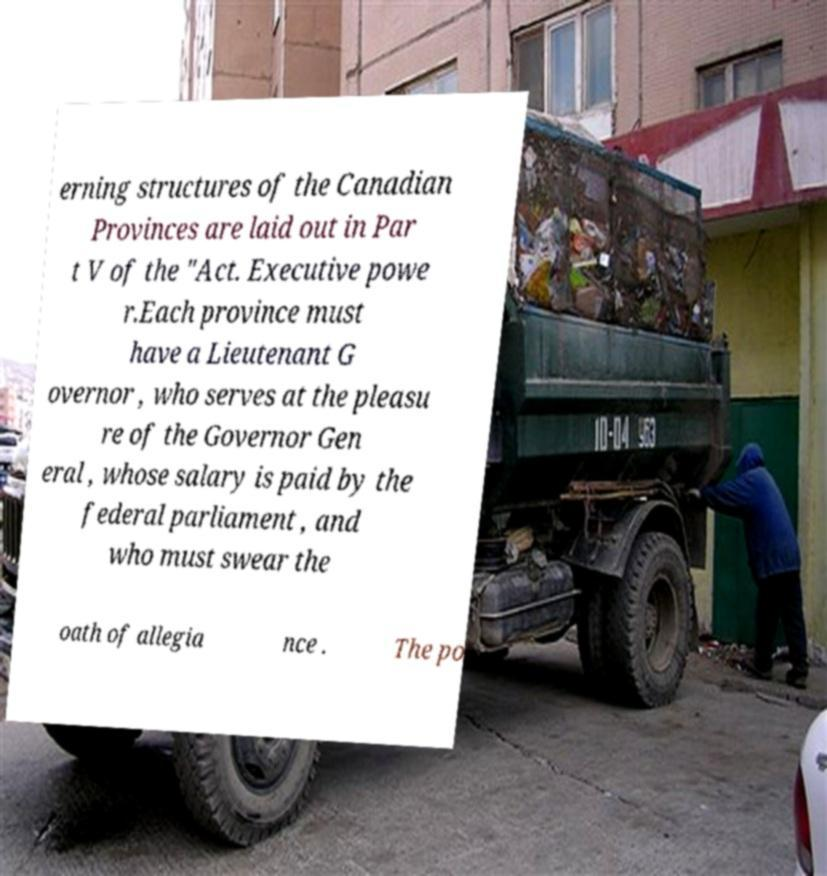Can you read and provide the text displayed in the image?This photo seems to have some interesting text. Can you extract and type it out for me? erning structures of the Canadian Provinces are laid out in Par t V of the "Act. Executive powe r.Each province must have a Lieutenant G overnor , who serves at the pleasu re of the Governor Gen eral , whose salary is paid by the federal parliament , and who must swear the oath of allegia nce . The po 